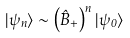<formula> <loc_0><loc_0><loc_500><loc_500>| \psi _ { n } \rangle \sim \left ( \hat { B } _ { + } \right ) ^ { n } | \psi _ { 0 } \rangle</formula> 